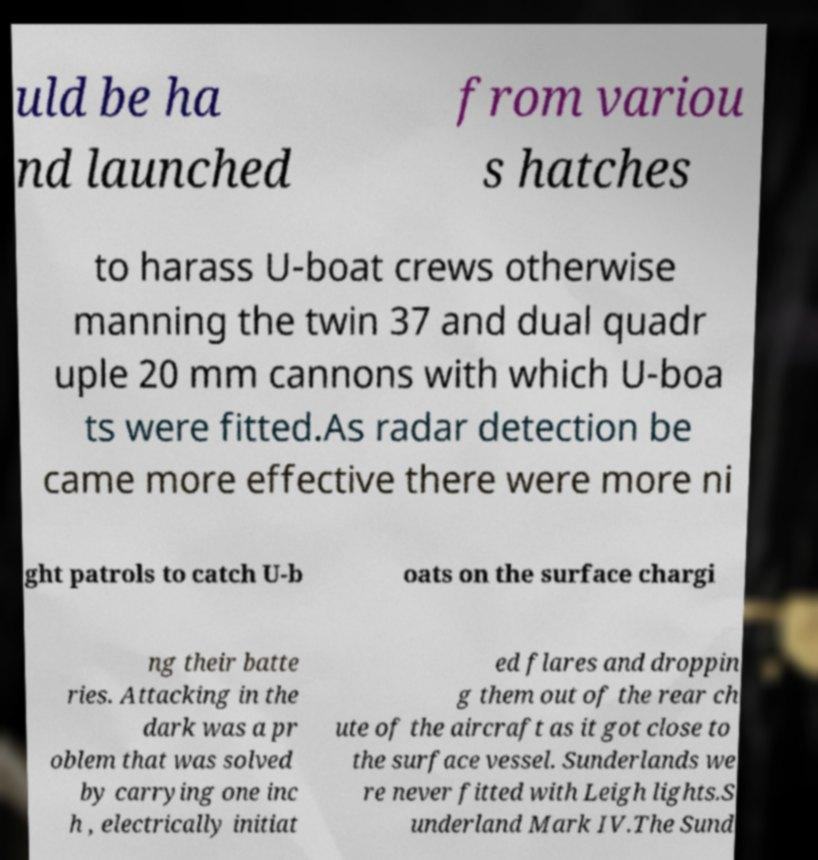Can you accurately transcribe the text from the provided image for me? uld be ha nd launched from variou s hatches to harass U-boat crews otherwise manning the twin 37 and dual quadr uple 20 mm cannons with which U-boa ts were fitted.As radar detection be came more effective there were more ni ght patrols to catch U-b oats on the surface chargi ng their batte ries. Attacking in the dark was a pr oblem that was solved by carrying one inc h , electrically initiat ed flares and droppin g them out of the rear ch ute of the aircraft as it got close to the surface vessel. Sunderlands we re never fitted with Leigh lights.S underland Mark IV.The Sund 